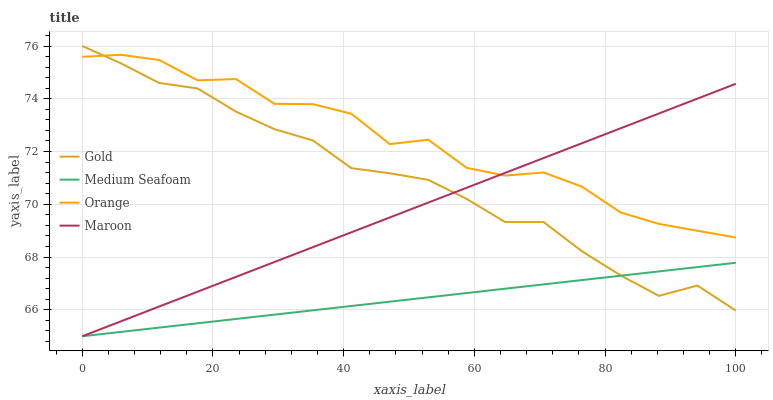Does Medium Seafoam have the minimum area under the curve?
Answer yes or no. Yes. Does Orange have the maximum area under the curve?
Answer yes or no. Yes. Does Maroon have the minimum area under the curve?
Answer yes or no. No. Does Maroon have the maximum area under the curve?
Answer yes or no. No. Is Maroon the smoothest?
Answer yes or no. Yes. Is Orange the roughest?
Answer yes or no. Yes. Is Medium Seafoam the smoothest?
Answer yes or no. No. Is Medium Seafoam the roughest?
Answer yes or no. No. Does Maroon have the lowest value?
Answer yes or no. Yes. Does Gold have the lowest value?
Answer yes or no. No. Does Gold have the highest value?
Answer yes or no. Yes. Does Maroon have the highest value?
Answer yes or no. No. Is Medium Seafoam less than Orange?
Answer yes or no. Yes. Is Orange greater than Medium Seafoam?
Answer yes or no. Yes. Does Medium Seafoam intersect Gold?
Answer yes or no. Yes. Is Medium Seafoam less than Gold?
Answer yes or no. No. Is Medium Seafoam greater than Gold?
Answer yes or no. No. Does Medium Seafoam intersect Orange?
Answer yes or no. No. 